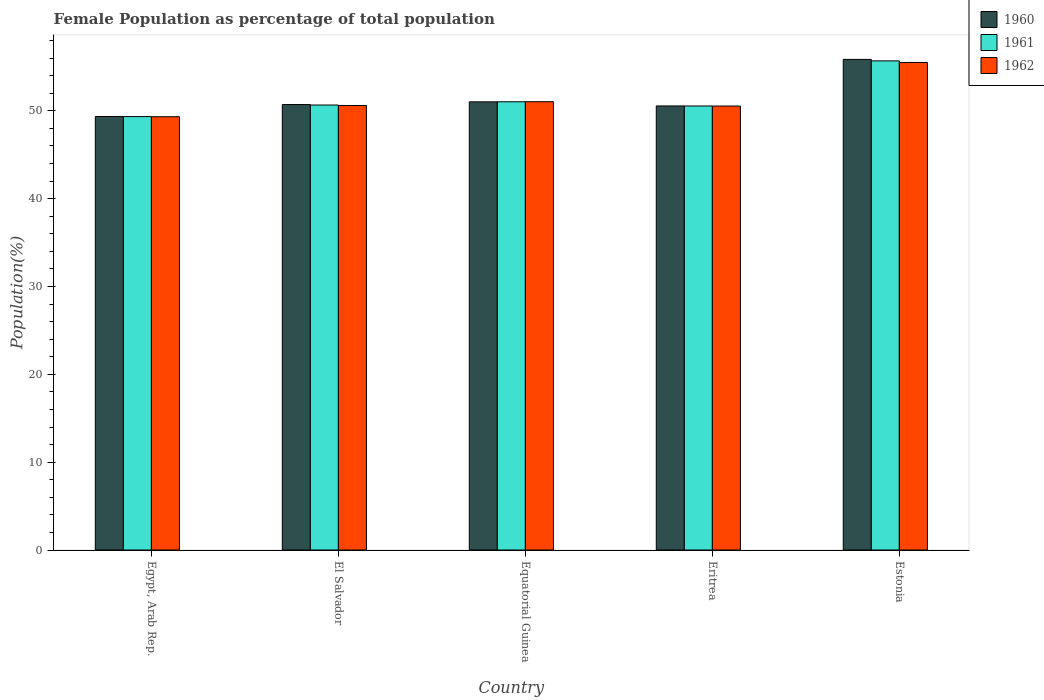How many different coloured bars are there?
Offer a very short reply. 3. How many groups of bars are there?
Provide a succinct answer. 5. How many bars are there on the 4th tick from the left?
Keep it short and to the point. 3. What is the label of the 4th group of bars from the left?
Offer a terse response. Eritrea. In how many cases, is the number of bars for a given country not equal to the number of legend labels?
Your answer should be compact. 0. What is the female population in in 1961 in El Salvador?
Your answer should be compact. 50.66. Across all countries, what is the maximum female population in in 1960?
Keep it short and to the point. 55.85. Across all countries, what is the minimum female population in in 1962?
Keep it short and to the point. 49.33. In which country was the female population in in 1960 maximum?
Make the answer very short. Estonia. In which country was the female population in in 1960 minimum?
Your response must be concise. Egypt, Arab Rep. What is the total female population in in 1961 in the graph?
Keep it short and to the point. 257.27. What is the difference between the female population in in 1961 in Equatorial Guinea and that in Estonia?
Provide a short and direct response. -4.66. What is the difference between the female population in in 1961 in Egypt, Arab Rep. and the female population in in 1962 in Equatorial Guinea?
Your answer should be very brief. -1.69. What is the average female population in in 1961 per country?
Offer a very short reply. 51.45. What is the difference between the female population in of/in 1960 and female population in of/in 1961 in Equatorial Guinea?
Ensure brevity in your answer.  -0.01. What is the ratio of the female population in in 1961 in Egypt, Arab Rep. to that in El Salvador?
Provide a succinct answer. 0.97. Is the female population in in 1960 in El Salvador less than that in Equatorial Guinea?
Ensure brevity in your answer.  Yes. What is the difference between the highest and the second highest female population in in 1962?
Keep it short and to the point. -0.43. What is the difference between the highest and the lowest female population in in 1960?
Offer a terse response. 6.5. Is the sum of the female population in in 1961 in Egypt, Arab Rep. and Estonia greater than the maximum female population in in 1962 across all countries?
Keep it short and to the point. Yes. What does the 2nd bar from the right in Estonia represents?
Your response must be concise. 1961. Is it the case that in every country, the sum of the female population in in 1962 and female population in in 1960 is greater than the female population in in 1961?
Ensure brevity in your answer.  Yes. How many bars are there?
Provide a short and direct response. 15. How many countries are there in the graph?
Provide a succinct answer. 5. What is the difference between two consecutive major ticks on the Y-axis?
Make the answer very short. 10. Are the values on the major ticks of Y-axis written in scientific E-notation?
Offer a terse response. No. How many legend labels are there?
Keep it short and to the point. 3. What is the title of the graph?
Keep it short and to the point. Female Population as percentage of total population. What is the label or title of the Y-axis?
Give a very brief answer. Population(%). What is the Population(%) of 1960 in Egypt, Arab Rep.?
Your answer should be very brief. 49.36. What is the Population(%) of 1961 in Egypt, Arab Rep.?
Give a very brief answer. 49.34. What is the Population(%) of 1962 in Egypt, Arab Rep.?
Provide a succinct answer. 49.33. What is the Population(%) of 1960 in El Salvador?
Your answer should be compact. 50.71. What is the Population(%) in 1961 in El Salvador?
Ensure brevity in your answer.  50.66. What is the Population(%) of 1962 in El Salvador?
Offer a very short reply. 50.6. What is the Population(%) in 1960 in Equatorial Guinea?
Offer a very short reply. 51.02. What is the Population(%) in 1961 in Equatorial Guinea?
Your answer should be very brief. 51.03. What is the Population(%) in 1962 in Equatorial Guinea?
Make the answer very short. 51.04. What is the Population(%) of 1960 in Eritrea?
Provide a short and direct response. 50.55. What is the Population(%) of 1961 in Eritrea?
Keep it short and to the point. 50.55. What is the Population(%) of 1962 in Eritrea?
Provide a succinct answer. 50.54. What is the Population(%) of 1960 in Estonia?
Provide a succinct answer. 55.85. What is the Population(%) in 1961 in Estonia?
Offer a very short reply. 55.69. What is the Population(%) of 1962 in Estonia?
Your answer should be compact. 55.51. Across all countries, what is the maximum Population(%) in 1960?
Ensure brevity in your answer.  55.85. Across all countries, what is the maximum Population(%) in 1961?
Your response must be concise. 55.69. Across all countries, what is the maximum Population(%) in 1962?
Offer a very short reply. 55.51. Across all countries, what is the minimum Population(%) in 1960?
Ensure brevity in your answer.  49.36. Across all countries, what is the minimum Population(%) in 1961?
Offer a terse response. 49.34. Across all countries, what is the minimum Population(%) of 1962?
Provide a short and direct response. 49.33. What is the total Population(%) in 1960 in the graph?
Keep it short and to the point. 257.5. What is the total Population(%) in 1961 in the graph?
Offer a very short reply. 257.27. What is the total Population(%) in 1962 in the graph?
Provide a short and direct response. 257.02. What is the difference between the Population(%) of 1960 in Egypt, Arab Rep. and that in El Salvador?
Offer a terse response. -1.36. What is the difference between the Population(%) of 1961 in Egypt, Arab Rep. and that in El Salvador?
Provide a short and direct response. -1.32. What is the difference between the Population(%) in 1962 in Egypt, Arab Rep. and that in El Salvador?
Provide a succinct answer. -1.27. What is the difference between the Population(%) in 1960 in Egypt, Arab Rep. and that in Equatorial Guinea?
Your answer should be very brief. -1.66. What is the difference between the Population(%) of 1961 in Egypt, Arab Rep. and that in Equatorial Guinea?
Keep it short and to the point. -1.69. What is the difference between the Population(%) of 1962 in Egypt, Arab Rep. and that in Equatorial Guinea?
Offer a terse response. -1.71. What is the difference between the Population(%) of 1960 in Egypt, Arab Rep. and that in Eritrea?
Keep it short and to the point. -1.2. What is the difference between the Population(%) in 1961 in Egypt, Arab Rep. and that in Eritrea?
Offer a terse response. -1.21. What is the difference between the Population(%) of 1962 in Egypt, Arab Rep. and that in Eritrea?
Offer a terse response. -1.21. What is the difference between the Population(%) in 1960 in Egypt, Arab Rep. and that in Estonia?
Keep it short and to the point. -6.5. What is the difference between the Population(%) in 1961 in Egypt, Arab Rep. and that in Estonia?
Your answer should be compact. -6.34. What is the difference between the Population(%) of 1962 in Egypt, Arab Rep. and that in Estonia?
Keep it short and to the point. -6.18. What is the difference between the Population(%) of 1960 in El Salvador and that in Equatorial Guinea?
Provide a succinct answer. -0.31. What is the difference between the Population(%) in 1961 in El Salvador and that in Equatorial Guinea?
Your answer should be very brief. -0.37. What is the difference between the Population(%) in 1962 in El Salvador and that in Equatorial Guinea?
Make the answer very short. -0.43. What is the difference between the Population(%) of 1960 in El Salvador and that in Eritrea?
Your response must be concise. 0.16. What is the difference between the Population(%) of 1961 in El Salvador and that in Eritrea?
Your answer should be compact. 0.11. What is the difference between the Population(%) of 1962 in El Salvador and that in Eritrea?
Offer a very short reply. 0.06. What is the difference between the Population(%) of 1960 in El Salvador and that in Estonia?
Your answer should be compact. -5.14. What is the difference between the Population(%) of 1961 in El Salvador and that in Estonia?
Your response must be concise. -5.03. What is the difference between the Population(%) in 1962 in El Salvador and that in Estonia?
Your response must be concise. -4.9. What is the difference between the Population(%) of 1960 in Equatorial Guinea and that in Eritrea?
Keep it short and to the point. 0.47. What is the difference between the Population(%) of 1961 in Equatorial Guinea and that in Eritrea?
Your answer should be very brief. 0.48. What is the difference between the Population(%) in 1962 in Equatorial Guinea and that in Eritrea?
Give a very brief answer. 0.49. What is the difference between the Population(%) in 1960 in Equatorial Guinea and that in Estonia?
Provide a short and direct response. -4.83. What is the difference between the Population(%) in 1961 in Equatorial Guinea and that in Estonia?
Make the answer very short. -4.66. What is the difference between the Population(%) of 1962 in Equatorial Guinea and that in Estonia?
Your answer should be compact. -4.47. What is the difference between the Population(%) in 1960 in Eritrea and that in Estonia?
Ensure brevity in your answer.  -5.3. What is the difference between the Population(%) of 1961 in Eritrea and that in Estonia?
Ensure brevity in your answer.  -5.14. What is the difference between the Population(%) of 1962 in Eritrea and that in Estonia?
Provide a short and direct response. -4.96. What is the difference between the Population(%) of 1960 in Egypt, Arab Rep. and the Population(%) of 1961 in El Salvador?
Your answer should be very brief. -1.3. What is the difference between the Population(%) of 1960 in Egypt, Arab Rep. and the Population(%) of 1962 in El Salvador?
Provide a succinct answer. -1.25. What is the difference between the Population(%) of 1961 in Egypt, Arab Rep. and the Population(%) of 1962 in El Salvador?
Your answer should be very brief. -1.26. What is the difference between the Population(%) in 1960 in Egypt, Arab Rep. and the Population(%) in 1961 in Equatorial Guinea?
Provide a succinct answer. -1.67. What is the difference between the Population(%) in 1960 in Egypt, Arab Rep. and the Population(%) in 1962 in Equatorial Guinea?
Keep it short and to the point. -1.68. What is the difference between the Population(%) in 1961 in Egypt, Arab Rep. and the Population(%) in 1962 in Equatorial Guinea?
Keep it short and to the point. -1.69. What is the difference between the Population(%) of 1960 in Egypt, Arab Rep. and the Population(%) of 1961 in Eritrea?
Keep it short and to the point. -1.19. What is the difference between the Population(%) of 1960 in Egypt, Arab Rep. and the Population(%) of 1962 in Eritrea?
Keep it short and to the point. -1.19. What is the difference between the Population(%) in 1961 in Egypt, Arab Rep. and the Population(%) in 1962 in Eritrea?
Your answer should be very brief. -1.2. What is the difference between the Population(%) in 1960 in Egypt, Arab Rep. and the Population(%) in 1961 in Estonia?
Provide a succinct answer. -6.33. What is the difference between the Population(%) of 1960 in Egypt, Arab Rep. and the Population(%) of 1962 in Estonia?
Provide a succinct answer. -6.15. What is the difference between the Population(%) in 1961 in Egypt, Arab Rep. and the Population(%) in 1962 in Estonia?
Ensure brevity in your answer.  -6.16. What is the difference between the Population(%) of 1960 in El Salvador and the Population(%) of 1961 in Equatorial Guinea?
Offer a very short reply. -0.32. What is the difference between the Population(%) in 1960 in El Salvador and the Population(%) in 1962 in Equatorial Guinea?
Give a very brief answer. -0.32. What is the difference between the Population(%) in 1961 in El Salvador and the Population(%) in 1962 in Equatorial Guinea?
Give a very brief answer. -0.38. What is the difference between the Population(%) in 1960 in El Salvador and the Population(%) in 1961 in Eritrea?
Offer a terse response. 0.16. What is the difference between the Population(%) of 1960 in El Salvador and the Population(%) of 1962 in Eritrea?
Give a very brief answer. 0.17. What is the difference between the Population(%) in 1961 in El Salvador and the Population(%) in 1962 in Eritrea?
Give a very brief answer. 0.12. What is the difference between the Population(%) of 1960 in El Salvador and the Population(%) of 1961 in Estonia?
Your response must be concise. -4.97. What is the difference between the Population(%) of 1960 in El Salvador and the Population(%) of 1962 in Estonia?
Ensure brevity in your answer.  -4.79. What is the difference between the Population(%) of 1961 in El Salvador and the Population(%) of 1962 in Estonia?
Give a very brief answer. -4.85. What is the difference between the Population(%) of 1960 in Equatorial Guinea and the Population(%) of 1961 in Eritrea?
Give a very brief answer. 0.47. What is the difference between the Population(%) of 1960 in Equatorial Guinea and the Population(%) of 1962 in Eritrea?
Your answer should be compact. 0.48. What is the difference between the Population(%) of 1961 in Equatorial Guinea and the Population(%) of 1962 in Eritrea?
Make the answer very short. 0.48. What is the difference between the Population(%) of 1960 in Equatorial Guinea and the Population(%) of 1961 in Estonia?
Provide a short and direct response. -4.67. What is the difference between the Population(%) in 1960 in Equatorial Guinea and the Population(%) in 1962 in Estonia?
Your answer should be very brief. -4.48. What is the difference between the Population(%) of 1961 in Equatorial Guinea and the Population(%) of 1962 in Estonia?
Your answer should be compact. -4.48. What is the difference between the Population(%) of 1960 in Eritrea and the Population(%) of 1961 in Estonia?
Provide a succinct answer. -5.13. What is the difference between the Population(%) of 1960 in Eritrea and the Population(%) of 1962 in Estonia?
Offer a very short reply. -4.95. What is the difference between the Population(%) of 1961 in Eritrea and the Population(%) of 1962 in Estonia?
Keep it short and to the point. -4.96. What is the average Population(%) of 1960 per country?
Make the answer very short. 51.5. What is the average Population(%) in 1961 per country?
Your response must be concise. 51.45. What is the average Population(%) in 1962 per country?
Give a very brief answer. 51.4. What is the difference between the Population(%) of 1960 and Population(%) of 1961 in Egypt, Arab Rep.?
Your answer should be compact. 0.01. What is the difference between the Population(%) of 1960 and Population(%) of 1962 in Egypt, Arab Rep.?
Make the answer very short. 0.03. What is the difference between the Population(%) in 1961 and Population(%) in 1962 in Egypt, Arab Rep.?
Your response must be concise. 0.01. What is the difference between the Population(%) in 1960 and Population(%) in 1961 in El Salvador?
Offer a terse response. 0.05. What is the difference between the Population(%) of 1960 and Population(%) of 1962 in El Salvador?
Your response must be concise. 0.11. What is the difference between the Population(%) of 1961 and Population(%) of 1962 in El Salvador?
Ensure brevity in your answer.  0.06. What is the difference between the Population(%) in 1960 and Population(%) in 1961 in Equatorial Guinea?
Provide a short and direct response. -0.01. What is the difference between the Population(%) of 1960 and Population(%) of 1962 in Equatorial Guinea?
Offer a very short reply. -0.02. What is the difference between the Population(%) of 1961 and Population(%) of 1962 in Equatorial Guinea?
Provide a short and direct response. -0.01. What is the difference between the Population(%) of 1960 and Population(%) of 1961 in Eritrea?
Make the answer very short. 0.01. What is the difference between the Population(%) in 1961 and Population(%) in 1962 in Eritrea?
Make the answer very short. 0.01. What is the difference between the Population(%) in 1960 and Population(%) in 1961 in Estonia?
Offer a very short reply. 0.17. What is the difference between the Population(%) in 1960 and Population(%) in 1962 in Estonia?
Give a very brief answer. 0.35. What is the difference between the Population(%) of 1961 and Population(%) of 1962 in Estonia?
Offer a terse response. 0.18. What is the ratio of the Population(%) of 1960 in Egypt, Arab Rep. to that in El Salvador?
Offer a terse response. 0.97. What is the ratio of the Population(%) of 1961 in Egypt, Arab Rep. to that in El Salvador?
Keep it short and to the point. 0.97. What is the ratio of the Population(%) of 1962 in Egypt, Arab Rep. to that in El Salvador?
Give a very brief answer. 0.97. What is the ratio of the Population(%) of 1960 in Egypt, Arab Rep. to that in Equatorial Guinea?
Your response must be concise. 0.97. What is the ratio of the Population(%) of 1961 in Egypt, Arab Rep. to that in Equatorial Guinea?
Your response must be concise. 0.97. What is the ratio of the Population(%) of 1962 in Egypt, Arab Rep. to that in Equatorial Guinea?
Offer a terse response. 0.97. What is the ratio of the Population(%) of 1960 in Egypt, Arab Rep. to that in Eritrea?
Provide a short and direct response. 0.98. What is the ratio of the Population(%) of 1961 in Egypt, Arab Rep. to that in Eritrea?
Your answer should be very brief. 0.98. What is the ratio of the Population(%) in 1962 in Egypt, Arab Rep. to that in Eritrea?
Your answer should be very brief. 0.98. What is the ratio of the Population(%) in 1960 in Egypt, Arab Rep. to that in Estonia?
Offer a very short reply. 0.88. What is the ratio of the Population(%) in 1961 in Egypt, Arab Rep. to that in Estonia?
Your response must be concise. 0.89. What is the ratio of the Population(%) of 1962 in Egypt, Arab Rep. to that in Estonia?
Provide a succinct answer. 0.89. What is the ratio of the Population(%) in 1960 in El Salvador to that in Equatorial Guinea?
Your response must be concise. 0.99. What is the ratio of the Population(%) in 1961 in El Salvador to that in Equatorial Guinea?
Offer a very short reply. 0.99. What is the ratio of the Population(%) of 1962 in El Salvador to that in Equatorial Guinea?
Ensure brevity in your answer.  0.99. What is the ratio of the Population(%) in 1962 in El Salvador to that in Eritrea?
Provide a short and direct response. 1. What is the ratio of the Population(%) of 1960 in El Salvador to that in Estonia?
Offer a terse response. 0.91. What is the ratio of the Population(%) in 1961 in El Salvador to that in Estonia?
Keep it short and to the point. 0.91. What is the ratio of the Population(%) in 1962 in El Salvador to that in Estonia?
Provide a succinct answer. 0.91. What is the ratio of the Population(%) in 1960 in Equatorial Guinea to that in Eritrea?
Offer a terse response. 1.01. What is the ratio of the Population(%) in 1961 in Equatorial Guinea to that in Eritrea?
Keep it short and to the point. 1.01. What is the ratio of the Population(%) of 1962 in Equatorial Guinea to that in Eritrea?
Provide a succinct answer. 1.01. What is the ratio of the Population(%) of 1960 in Equatorial Guinea to that in Estonia?
Your response must be concise. 0.91. What is the ratio of the Population(%) in 1961 in Equatorial Guinea to that in Estonia?
Keep it short and to the point. 0.92. What is the ratio of the Population(%) of 1962 in Equatorial Guinea to that in Estonia?
Ensure brevity in your answer.  0.92. What is the ratio of the Population(%) of 1960 in Eritrea to that in Estonia?
Make the answer very short. 0.91. What is the ratio of the Population(%) of 1961 in Eritrea to that in Estonia?
Your answer should be compact. 0.91. What is the ratio of the Population(%) of 1962 in Eritrea to that in Estonia?
Keep it short and to the point. 0.91. What is the difference between the highest and the second highest Population(%) of 1960?
Provide a succinct answer. 4.83. What is the difference between the highest and the second highest Population(%) in 1961?
Your response must be concise. 4.66. What is the difference between the highest and the second highest Population(%) in 1962?
Make the answer very short. 4.47. What is the difference between the highest and the lowest Population(%) of 1960?
Your answer should be compact. 6.5. What is the difference between the highest and the lowest Population(%) of 1961?
Offer a terse response. 6.34. What is the difference between the highest and the lowest Population(%) of 1962?
Make the answer very short. 6.18. 